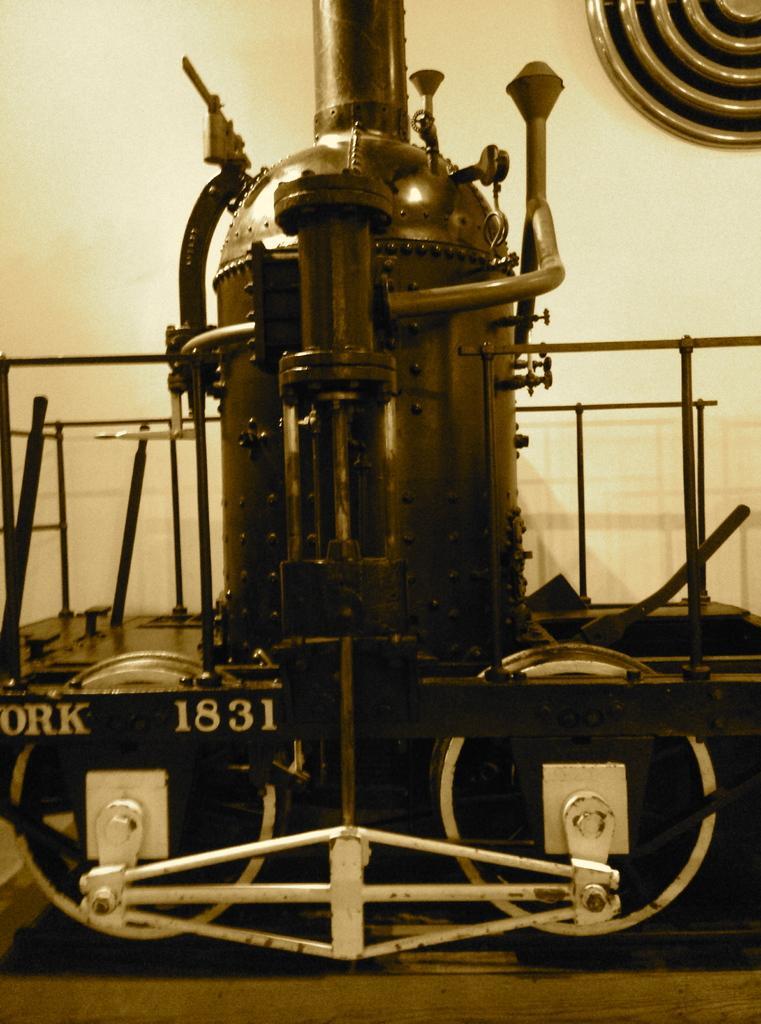Please provide a concise description of this image. In this image we can see a machine with the metal poles and wheels which is placed on the surface. On the backside we can see a wall. 